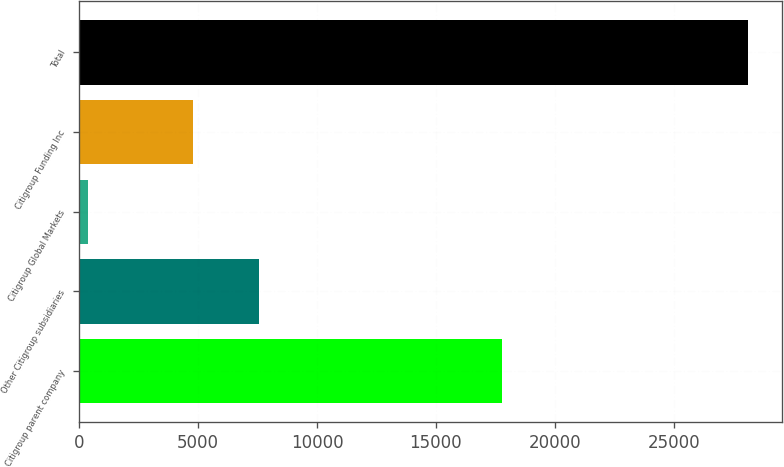<chart> <loc_0><loc_0><loc_500><loc_500><bar_chart><fcel>Citigroup parent company<fcel>Other Citigroup subsidiaries<fcel>Citigroup Global Markets<fcel>Citigroup Funding Inc<fcel>Total<nl><fcel>17775<fcel>7566.4<fcel>388<fcel>4792<fcel>28132<nl></chart> 